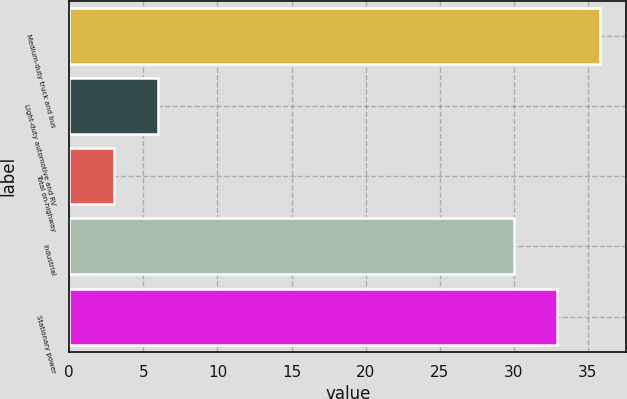<chart> <loc_0><loc_0><loc_500><loc_500><bar_chart><fcel>Medium-duty truck and bus<fcel>Light-duty automotive and RV<fcel>Total on-highway<fcel>Industrial<fcel>Stationary power<nl><fcel>35.8<fcel>6<fcel>3<fcel>30<fcel>32.9<nl></chart> 